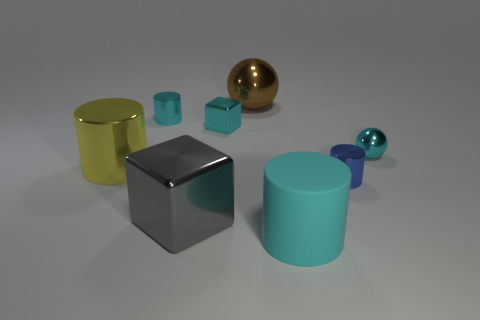What shape is the big object that is the same color as the small metal ball?
Provide a succinct answer. Cylinder. Is the color of the small metallic sphere the same as the matte thing?
Provide a short and direct response. Yes. There is a large yellow object that is the same material as the gray thing; what is its shape?
Your answer should be compact. Cylinder. There is a cyan thing that is right of the big cyan object; what is its size?
Provide a succinct answer. Small. What is the shape of the big brown metal thing?
Provide a short and direct response. Sphere. Does the cyan cylinder that is on the right side of the small cyan cube have the same size as the cylinder to the right of the large cyan matte cylinder?
Offer a very short reply. No. There is a metallic sphere that is on the right side of the cyan cylinder that is in front of the cyan cylinder that is behind the cyan rubber thing; what size is it?
Your response must be concise. Small. What shape is the large metal object that is behind the shiny object that is to the left of the small metallic cylinder left of the brown ball?
Provide a short and direct response. Sphere. What is the shape of the tiny metal object that is in front of the cyan metallic sphere?
Provide a short and direct response. Cylinder. Does the gray cube have the same material as the cyan object in front of the small metallic sphere?
Offer a terse response. No. 